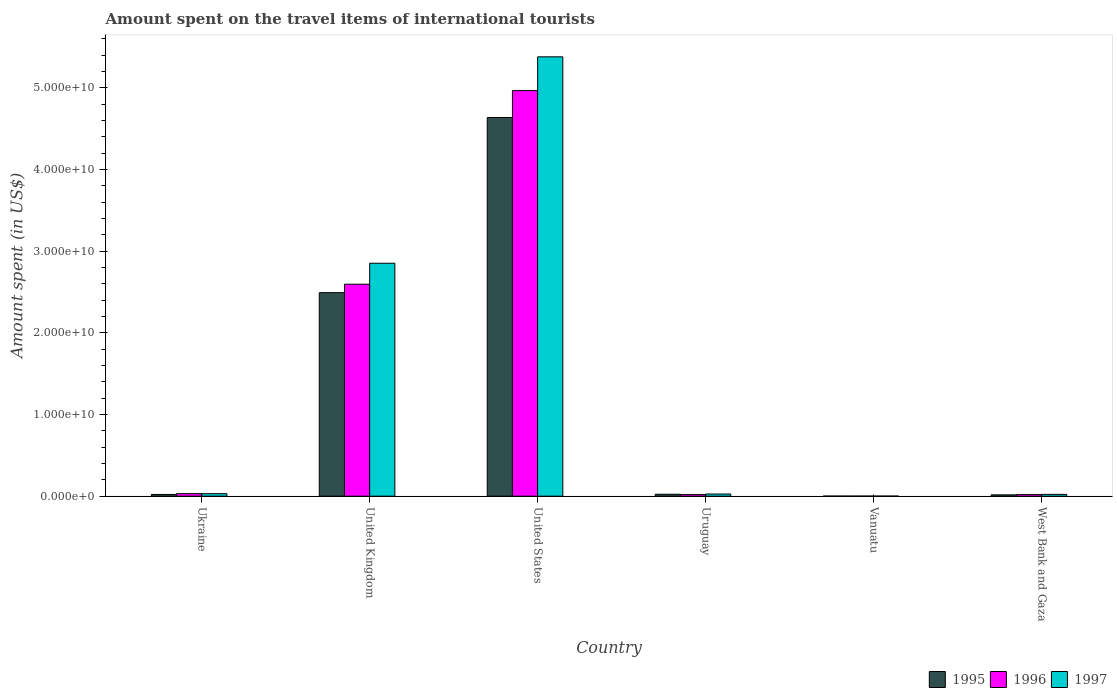How many different coloured bars are there?
Make the answer very short. 3. Are the number of bars per tick equal to the number of legend labels?
Give a very brief answer. Yes. Are the number of bars on each tick of the X-axis equal?
Give a very brief answer. Yes. How many bars are there on the 1st tick from the right?
Provide a succinct answer. 3. What is the label of the 1st group of bars from the left?
Make the answer very short. Ukraine. In how many cases, is the number of bars for a given country not equal to the number of legend labels?
Give a very brief answer. 0. What is the amount spent on the travel items of international tourists in 1995 in Vanuatu?
Give a very brief answer. 5.00e+06. Across all countries, what is the maximum amount spent on the travel items of international tourists in 1996?
Your response must be concise. 4.97e+1. In which country was the amount spent on the travel items of international tourists in 1995 maximum?
Provide a succinct answer. United States. In which country was the amount spent on the travel items of international tourists in 1996 minimum?
Ensure brevity in your answer.  Vanuatu. What is the total amount spent on the travel items of international tourists in 1997 in the graph?
Ensure brevity in your answer.  8.31e+1. What is the difference between the amount spent on the travel items of international tourists in 1996 in Ukraine and that in West Bank and Gaza?
Your answer should be compact. 1.17e+08. What is the difference between the amount spent on the travel items of international tourists in 1996 in West Bank and Gaza and the amount spent on the travel items of international tourists in 1995 in United Kingdom?
Keep it short and to the point. -2.47e+1. What is the average amount spent on the travel items of international tourists in 1996 per country?
Ensure brevity in your answer.  1.27e+1. What is the difference between the amount spent on the travel items of international tourists of/in 1995 and amount spent on the travel items of international tourists of/in 1997 in United States?
Your answer should be very brief. -7.43e+09. What is the ratio of the amount spent on the travel items of international tourists in 1996 in Ukraine to that in United States?
Make the answer very short. 0.01. Is the difference between the amount spent on the travel items of international tourists in 1995 in Uruguay and Vanuatu greater than the difference between the amount spent on the travel items of international tourists in 1997 in Uruguay and Vanuatu?
Offer a terse response. No. What is the difference between the highest and the second highest amount spent on the travel items of international tourists in 1995?
Offer a terse response. 4.61e+1. What is the difference between the highest and the lowest amount spent on the travel items of international tourists in 1997?
Offer a terse response. 5.38e+1. In how many countries, is the amount spent on the travel items of international tourists in 1996 greater than the average amount spent on the travel items of international tourists in 1996 taken over all countries?
Your answer should be very brief. 2. What does the 3rd bar from the left in Uruguay represents?
Your answer should be compact. 1997. What does the 3rd bar from the right in West Bank and Gaza represents?
Provide a succinct answer. 1995. How many countries are there in the graph?
Make the answer very short. 6. Are the values on the major ticks of Y-axis written in scientific E-notation?
Keep it short and to the point. Yes. Does the graph contain any zero values?
Give a very brief answer. No. Does the graph contain grids?
Give a very brief answer. No. How many legend labels are there?
Offer a very short reply. 3. What is the title of the graph?
Your response must be concise. Amount spent on the travel items of international tourists. What is the label or title of the X-axis?
Ensure brevity in your answer.  Country. What is the label or title of the Y-axis?
Your answer should be very brief. Amount spent (in US$). What is the Amount spent (in US$) in 1995 in Ukraine?
Your answer should be very brief. 2.10e+08. What is the Amount spent (in US$) in 1996 in Ukraine?
Provide a short and direct response. 3.08e+08. What is the Amount spent (in US$) in 1997 in Ukraine?
Offer a very short reply. 3.05e+08. What is the Amount spent (in US$) in 1995 in United Kingdom?
Your answer should be very brief. 2.49e+1. What is the Amount spent (in US$) of 1996 in United Kingdom?
Your answer should be compact. 2.60e+1. What is the Amount spent (in US$) in 1997 in United Kingdom?
Keep it short and to the point. 2.85e+1. What is the Amount spent (in US$) in 1995 in United States?
Offer a very short reply. 4.64e+1. What is the Amount spent (in US$) in 1996 in United States?
Offer a very short reply. 4.97e+1. What is the Amount spent (in US$) of 1997 in United States?
Offer a terse response. 5.38e+1. What is the Amount spent (in US$) in 1995 in Uruguay?
Give a very brief answer. 2.36e+08. What is the Amount spent (in US$) of 1996 in Uruguay?
Offer a very short reply. 1.92e+08. What is the Amount spent (in US$) of 1997 in Uruguay?
Your response must be concise. 2.64e+08. What is the Amount spent (in US$) in 1996 in Vanuatu?
Provide a succinct answer. 5.00e+06. What is the Amount spent (in US$) in 1995 in West Bank and Gaza?
Your answer should be very brief. 1.62e+08. What is the Amount spent (in US$) of 1996 in West Bank and Gaza?
Offer a terse response. 1.91e+08. What is the Amount spent (in US$) in 1997 in West Bank and Gaza?
Your response must be concise. 2.18e+08. Across all countries, what is the maximum Amount spent (in US$) of 1995?
Provide a succinct answer. 4.64e+1. Across all countries, what is the maximum Amount spent (in US$) of 1996?
Offer a terse response. 4.97e+1. Across all countries, what is the maximum Amount spent (in US$) of 1997?
Keep it short and to the point. 5.38e+1. Across all countries, what is the minimum Amount spent (in US$) of 1996?
Your answer should be compact. 5.00e+06. What is the total Amount spent (in US$) in 1995 in the graph?
Keep it short and to the point. 7.19e+1. What is the total Amount spent (in US$) of 1996 in the graph?
Provide a succinct answer. 7.63e+1. What is the total Amount spent (in US$) in 1997 in the graph?
Offer a terse response. 8.31e+1. What is the difference between the Amount spent (in US$) in 1995 in Ukraine and that in United Kingdom?
Your answer should be compact. -2.47e+1. What is the difference between the Amount spent (in US$) of 1996 in Ukraine and that in United Kingdom?
Your response must be concise. -2.57e+1. What is the difference between the Amount spent (in US$) in 1997 in Ukraine and that in United Kingdom?
Provide a short and direct response. -2.82e+1. What is the difference between the Amount spent (in US$) of 1995 in Ukraine and that in United States?
Make the answer very short. -4.62e+1. What is the difference between the Amount spent (in US$) in 1996 in Ukraine and that in United States?
Your answer should be compact. -4.94e+1. What is the difference between the Amount spent (in US$) of 1997 in Ukraine and that in United States?
Ensure brevity in your answer.  -5.35e+1. What is the difference between the Amount spent (in US$) of 1995 in Ukraine and that in Uruguay?
Make the answer very short. -2.60e+07. What is the difference between the Amount spent (in US$) in 1996 in Ukraine and that in Uruguay?
Make the answer very short. 1.16e+08. What is the difference between the Amount spent (in US$) of 1997 in Ukraine and that in Uruguay?
Your answer should be very brief. 4.10e+07. What is the difference between the Amount spent (in US$) in 1995 in Ukraine and that in Vanuatu?
Offer a very short reply. 2.05e+08. What is the difference between the Amount spent (in US$) of 1996 in Ukraine and that in Vanuatu?
Your answer should be very brief. 3.03e+08. What is the difference between the Amount spent (in US$) of 1997 in Ukraine and that in Vanuatu?
Make the answer very short. 3.00e+08. What is the difference between the Amount spent (in US$) of 1995 in Ukraine and that in West Bank and Gaza?
Offer a very short reply. 4.80e+07. What is the difference between the Amount spent (in US$) in 1996 in Ukraine and that in West Bank and Gaza?
Provide a short and direct response. 1.17e+08. What is the difference between the Amount spent (in US$) of 1997 in Ukraine and that in West Bank and Gaza?
Make the answer very short. 8.70e+07. What is the difference between the Amount spent (in US$) in 1995 in United Kingdom and that in United States?
Your answer should be very brief. -2.15e+1. What is the difference between the Amount spent (in US$) of 1996 in United Kingdom and that in United States?
Make the answer very short. -2.37e+1. What is the difference between the Amount spent (in US$) of 1997 in United Kingdom and that in United States?
Ensure brevity in your answer.  -2.53e+1. What is the difference between the Amount spent (in US$) of 1995 in United Kingdom and that in Uruguay?
Your response must be concise. 2.47e+1. What is the difference between the Amount spent (in US$) in 1996 in United Kingdom and that in Uruguay?
Make the answer very short. 2.58e+1. What is the difference between the Amount spent (in US$) in 1997 in United Kingdom and that in Uruguay?
Make the answer very short. 2.83e+1. What is the difference between the Amount spent (in US$) in 1995 in United Kingdom and that in Vanuatu?
Offer a terse response. 2.49e+1. What is the difference between the Amount spent (in US$) in 1996 in United Kingdom and that in Vanuatu?
Provide a short and direct response. 2.60e+1. What is the difference between the Amount spent (in US$) in 1997 in United Kingdom and that in Vanuatu?
Provide a succinct answer. 2.85e+1. What is the difference between the Amount spent (in US$) in 1995 in United Kingdom and that in West Bank and Gaza?
Give a very brief answer. 2.48e+1. What is the difference between the Amount spent (in US$) in 1996 in United Kingdom and that in West Bank and Gaza?
Provide a short and direct response. 2.58e+1. What is the difference between the Amount spent (in US$) of 1997 in United Kingdom and that in West Bank and Gaza?
Ensure brevity in your answer.  2.83e+1. What is the difference between the Amount spent (in US$) of 1995 in United States and that in Uruguay?
Provide a short and direct response. 4.61e+1. What is the difference between the Amount spent (in US$) of 1996 in United States and that in Uruguay?
Ensure brevity in your answer.  4.95e+1. What is the difference between the Amount spent (in US$) of 1997 in United States and that in Uruguay?
Give a very brief answer. 5.35e+1. What is the difference between the Amount spent (in US$) in 1995 in United States and that in Vanuatu?
Provide a succinct answer. 4.64e+1. What is the difference between the Amount spent (in US$) in 1996 in United States and that in Vanuatu?
Your answer should be compact. 4.97e+1. What is the difference between the Amount spent (in US$) of 1997 in United States and that in Vanuatu?
Offer a terse response. 5.38e+1. What is the difference between the Amount spent (in US$) of 1995 in United States and that in West Bank and Gaza?
Provide a succinct answer. 4.62e+1. What is the difference between the Amount spent (in US$) in 1996 in United States and that in West Bank and Gaza?
Offer a terse response. 4.95e+1. What is the difference between the Amount spent (in US$) in 1997 in United States and that in West Bank and Gaza?
Provide a succinct answer. 5.36e+1. What is the difference between the Amount spent (in US$) in 1995 in Uruguay and that in Vanuatu?
Your answer should be very brief. 2.31e+08. What is the difference between the Amount spent (in US$) of 1996 in Uruguay and that in Vanuatu?
Ensure brevity in your answer.  1.87e+08. What is the difference between the Amount spent (in US$) in 1997 in Uruguay and that in Vanuatu?
Your answer should be compact. 2.59e+08. What is the difference between the Amount spent (in US$) in 1995 in Uruguay and that in West Bank and Gaza?
Ensure brevity in your answer.  7.40e+07. What is the difference between the Amount spent (in US$) of 1996 in Uruguay and that in West Bank and Gaza?
Your answer should be very brief. 1.00e+06. What is the difference between the Amount spent (in US$) in 1997 in Uruguay and that in West Bank and Gaza?
Keep it short and to the point. 4.60e+07. What is the difference between the Amount spent (in US$) of 1995 in Vanuatu and that in West Bank and Gaza?
Your answer should be compact. -1.57e+08. What is the difference between the Amount spent (in US$) of 1996 in Vanuatu and that in West Bank and Gaza?
Make the answer very short. -1.86e+08. What is the difference between the Amount spent (in US$) in 1997 in Vanuatu and that in West Bank and Gaza?
Provide a short and direct response. -2.13e+08. What is the difference between the Amount spent (in US$) of 1995 in Ukraine and the Amount spent (in US$) of 1996 in United Kingdom?
Make the answer very short. -2.58e+1. What is the difference between the Amount spent (in US$) in 1995 in Ukraine and the Amount spent (in US$) in 1997 in United Kingdom?
Your answer should be very brief. -2.83e+1. What is the difference between the Amount spent (in US$) of 1996 in Ukraine and the Amount spent (in US$) of 1997 in United Kingdom?
Keep it short and to the point. -2.82e+1. What is the difference between the Amount spent (in US$) of 1995 in Ukraine and the Amount spent (in US$) of 1996 in United States?
Ensure brevity in your answer.  -4.95e+1. What is the difference between the Amount spent (in US$) of 1995 in Ukraine and the Amount spent (in US$) of 1997 in United States?
Keep it short and to the point. -5.36e+1. What is the difference between the Amount spent (in US$) of 1996 in Ukraine and the Amount spent (in US$) of 1997 in United States?
Make the answer very short. -5.35e+1. What is the difference between the Amount spent (in US$) of 1995 in Ukraine and the Amount spent (in US$) of 1996 in Uruguay?
Ensure brevity in your answer.  1.80e+07. What is the difference between the Amount spent (in US$) in 1995 in Ukraine and the Amount spent (in US$) in 1997 in Uruguay?
Offer a very short reply. -5.40e+07. What is the difference between the Amount spent (in US$) in 1996 in Ukraine and the Amount spent (in US$) in 1997 in Uruguay?
Make the answer very short. 4.40e+07. What is the difference between the Amount spent (in US$) in 1995 in Ukraine and the Amount spent (in US$) in 1996 in Vanuatu?
Provide a succinct answer. 2.05e+08. What is the difference between the Amount spent (in US$) in 1995 in Ukraine and the Amount spent (in US$) in 1997 in Vanuatu?
Provide a short and direct response. 2.05e+08. What is the difference between the Amount spent (in US$) of 1996 in Ukraine and the Amount spent (in US$) of 1997 in Vanuatu?
Offer a very short reply. 3.03e+08. What is the difference between the Amount spent (in US$) in 1995 in Ukraine and the Amount spent (in US$) in 1996 in West Bank and Gaza?
Your answer should be very brief. 1.90e+07. What is the difference between the Amount spent (in US$) in 1995 in Ukraine and the Amount spent (in US$) in 1997 in West Bank and Gaza?
Your response must be concise. -8.00e+06. What is the difference between the Amount spent (in US$) in 1996 in Ukraine and the Amount spent (in US$) in 1997 in West Bank and Gaza?
Your answer should be compact. 9.00e+07. What is the difference between the Amount spent (in US$) in 1995 in United Kingdom and the Amount spent (in US$) in 1996 in United States?
Your answer should be compact. -2.47e+1. What is the difference between the Amount spent (in US$) of 1995 in United Kingdom and the Amount spent (in US$) of 1997 in United States?
Offer a very short reply. -2.89e+1. What is the difference between the Amount spent (in US$) of 1996 in United Kingdom and the Amount spent (in US$) of 1997 in United States?
Offer a terse response. -2.78e+1. What is the difference between the Amount spent (in US$) in 1995 in United Kingdom and the Amount spent (in US$) in 1996 in Uruguay?
Provide a short and direct response. 2.47e+1. What is the difference between the Amount spent (in US$) of 1995 in United Kingdom and the Amount spent (in US$) of 1997 in Uruguay?
Provide a short and direct response. 2.47e+1. What is the difference between the Amount spent (in US$) of 1996 in United Kingdom and the Amount spent (in US$) of 1997 in Uruguay?
Your response must be concise. 2.57e+1. What is the difference between the Amount spent (in US$) of 1995 in United Kingdom and the Amount spent (in US$) of 1996 in Vanuatu?
Provide a succinct answer. 2.49e+1. What is the difference between the Amount spent (in US$) of 1995 in United Kingdom and the Amount spent (in US$) of 1997 in Vanuatu?
Ensure brevity in your answer.  2.49e+1. What is the difference between the Amount spent (in US$) of 1996 in United Kingdom and the Amount spent (in US$) of 1997 in Vanuatu?
Your answer should be compact. 2.60e+1. What is the difference between the Amount spent (in US$) of 1995 in United Kingdom and the Amount spent (in US$) of 1996 in West Bank and Gaza?
Give a very brief answer. 2.47e+1. What is the difference between the Amount spent (in US$) of 1995 in United Kingdom and the Amount spent (in US$) of 1997 in West Bank and Gaza?
Ensure brevity in your answer.  2.47e+1. What is the difference between the Amount spent (in US$) of 1996 in United Kingdom and the Amount spent (in US$) of 1997 in West Bank and Gaza?
Ensure brevity in your answer.  2.57e+1. What is the difference between the Amount spent (in US$) in 1995 in United States and the Amount spent (in US$) in 1996 in Uruguay?
Give a very brief answer. 4.62e+1. What is the difference between the Amount spent (in US$) of 1995 in United States and the Amount spent (in US$) of 1997 in Uruguay?
Provide a short and direct response. 4.61e+1. What is the difference between the Amount spent (in US$) in 1996 in United States and the Amount spent (in US$) in 1997 in Uruguay?
Provide a succinct answer. 4.94e+1. What is the difference between the Amount spent (in US$) of 1995 in United States and the Amount spent (in US$) of 1996 in Vanuatu?
Your answer should be compact. 4.64e+1. What is the difference between the Amount spent (in US$) in 1995 in United States and the Amount spent (in US$) in 1997 in Vanuatu?
Provide a short and direct response. 4.64e+1. What is the difference between the Amount spent (in US$) in 1996 in United States and the Amount spent (in US$) in 1997 in Vanuatu?
Your answer should be very brief. 4.97e+1. What is the difference between the Amount spent (in US$) in 1995 in United States and the Amount spent (in US$) in 1996 in West Bank and Gaza?
Your answer should be very brief. 4.62e+1. What is the difference between the Amount spent (in US$) of 1995 in United States and the Amount spent (in US$) of 1997 in West Bank and Gaza?
Ensure brevity in your answer.  4.62e+1. What is the difference between the Amount spent (in US$) of 1996 in United States and the Amount spent (in US$) of 1997 in West Bank and Gaza?
Keep it short and to the point. 4.95e+1. What is the difference between the Amount spent (in US$) in 1995 in Uruguay and the Amount spent (in US$) in 1996 in Vanuatu?
Provide a short and direct response. 2.31e+08. What is the difference between the Amount spent (in US$) of 1995 in Uruguay and the Amount spent (in US$) of 1997 in Vanuatu?
Your response must be concise. 2.31e+08. What is the difference between the Amount spent (in US$) of 1996 in Uruguay and the Amount spent (in US$) of 1997 in Vanuatu?
Make the answer very short. 1.87e+08. What is the difference between the Amount spent (in US$) of 1995 in Uruguay and the Amount spent (in US$) of 1996 in West Bank and Gaza?
Ensure brevity in your answer.  4.50e+07. What is the difference between the Amount spent (in US$) of 1995 in Uruguay and the Amount spent (in US$) of 1997 in West Bank and Gaza?
Your answer should be compact. 1.80e+07. What is the difference between the Amount spent (in US$) in 1996 in Uruguay and the Amount spent (in US$) in 1997 in West Bank and Gaza?
Offer a very short reply. -2.60e+07. What is the difference between the Amount spent (in US$) of 1995 in Vanuatu and the Amount spent (in US$) of 1996 in West Bank and Gaza?
Your response must be concise. -1.86e+08. What is the difference between the Amount spent (in US$) of 1995 in Vanuatu and the Amount spent (in US$) of 1997 in West Bank and Gaza?
Provide a succinct answer. -2.13e+08. What is the difference between the Amount spent (in US$) of 1996 in Vanuatu and the Amount spent (in US$) of 1997 in West Bank and Gaza?
Your answer should be very brief. -2.13e+08. What is the average Amount spent (in US$) of 1995 per country?
Keep it short and to the point. 1.20e+1. What is the average Amount spent (in US$) in 1996 per country?
Give a very brief answer. 1.27e+1. What is the average Amount spent (in US$) in 1997 per country?
Your response must be concise. 1.39e+1. What is the difference between the Amount spent (in US$) in 1995 and Amount spent (in US$) in 1996 in Ukraine?
Offer a terse response. -9.80e+07. What is the difference between the Amount spent (in US$) in 1995 and Amount spent (in US$) in 1997 in Ukraine?
Your answer should be compact. -9.50e+07. What is the difference between the Amount spent (in US$) of 1995 and Amount spent (in US$) of 1996 in United Kingdom?
Your response must be concise. -1.04e+09. What is the difference between the Amount spent (in US$) in 1995 and Amount spent (in US$) in 1997 in United Kingdom?
Your answer should be compact. -3.60e+09. What is the difference between the Amount spent (in US$) of 1996 and Amount spent (in US$) of 1997 in United Kingdom?
Give a very brief answer. -2.57e+09. What is the difference between the Amount spent (in US$) of 1995 and Amount spent (in US$) of 1996 in United States?
Your response must be concise. -3.29e+09. What is the difference between the Amount spent (in US$) of 1995 and Amount spent (in US$) of 1997 in United States?
Keep it short and to the point. -7.43e+09. What is the difference between the Amount spent (in US$) in 1996 and Amount spent (in US$) in 1997 in United States?
Give a very brief answer. -4.14e+09. What is the difference between the Amount spent (in US$) in 1995 and Amount spent (in US$) in 1996 in Uruguay?
Your answer should be very brief. 4.40e+07. What is the difference between the Amount spent (in US$) of 1995 and Amount spent (in US$) of 1997 in Uruguay?
Ensure brevity in your answer.  -2.80e+07. What is the difference between the Amount spent (in US$) in 1996 and Amount spent (in US$) in 1997 in Uruguay?
Your answer should be very brief. -7.20e+07. What is the difference between the Amount spent (in US$) of 1995 and Amount spent (in US$) of 1996 in Vanuatu?
Your answer should be compact. 0. What is the difference between the Amount spent (in US$) in 1996 and Amount spent (in US$) in 1997 in Vanuatu?
Keep it short and to the point. 0. What is the difference between the Amount spent (in US$) of 1995 and Amount spent (in US$) of 1996 in West Bank and Gaza?
Provide a succinct answer. -2.90e+07. What is the difference between the Amount spent (in US$) of 1995 and Amount spent (in US$) of 1997 in West Bank and Gaza?
Provide a succinct answer. -5.60e+07. What is the difference between the Amount spent (in US$) in 1996 and Amount spent (in US$) in 1997 in West Bank and Gaza?
Keep it short and to the point. -2.70e+07. What is the ratio of the Amount spent (in US$) of 1995 in Ukraine to that in United Kingdom?
Give a very brief answer. 0.01. What is the ratio of the Amount spent (in US$) of 1996 in Ukraine to that in United Kingdom?
Your response must be concise. 0.01. What is the ratio of the Amount spent (in US$) in 1997 in Ukraine to that in United Kingdom?
Your answer should be very brief. 0.01. What is the ratio of the Amount spent (in US$) of 1995 in Ukraine to that in United States?
Keep it short and to the point. 0. What is the ratio of the Amount spent (in US$) of 1996 in Ukraine to that in United States?
Your response must be concise. 0.01. What is the ratio of the Amount spent (in US$) of 1997 in Ukraine to that in United States?
Give a very brief answer. 0.01. What is the ratio of the Amount spent (in US$) in 1995 in Ukraine to that in Uruguay?
Your answer should be very brief. 0.89. What is the ratio of the Amount spent (in US$) in 1996 in Ukraine to that in Uruguay?
Your answer should be compact. 1.6. What is the ratio of the Amount spent (in US$) in 1997 in Ukraine to that in Uruguay?
Your answer should be very brief. 1.16. What is the ratio of the Amount spent (in US$) of 1995 in Ukraine to that in Vanuatu?
Keep it short and to the point. 42. What is the ratio of the Amount spent (in US$) of 1996 in Ukraine to that in Vanuatu?
Provide a succinct answer. 61.6. What is the ratio of the Amount spent (in US$) in 1997 in Ukraine to that in Vanuatu?
Offer a terse response. 61. What is the ratio of the Amount spent (in US$) of 1995 in Ukraine to that in West Bank and Gaza?
Offer a terse response. 1.3. What is the ratio of the Amount spent (in US$) of 1996 in Ukraine to that in West Bank and Gaza?
Offer a very short reply. 1.61. What is the ratio of the Amount spent (in US$) of 1997 in Ukraine to that in West Bank and Gaza?
Offer a terse response. 1.4. What is the ratio of the Amount spent (in US$) of 1995 in United Kingdom to that in United States?
Offer a very short reply. 0.54. What is the ratio of the Amount spent (in US$) of 1996 in United Kingdom to that in United States?
Provide a short and direct response. 0.52. What is the ratio of the Amount spent (in US$) in 1997 in United Kingdom to that in United States?
Provide a succinct answer. 0.53. What is the ratio of the Amount spent (in US$) of 1995 in United Kingdom to that in Uruguay?
Give a very brief answer. 105.62. What is the ratio of the Amount spent (in US$) of 1996 in United Kingdom to that in Uruguay?
Make the answer very short. 135.22. What is the ratio of the Amount spent (in US$) of 1997 in United Kingdom to that in Uruguay?
Offer a terse response. 108.06. What is the ratio of the Amount spent (in US$) in 1995 in United Kingdom to that in Vanuatu?
Give a very brief answer. 4985.2. What is the ratio of the Amount spent (in US$) in 1996 in United Kingdom to that in Vanuatu?
Provide a short and direct response. 5192.4. What is the ratio of the Amount spent (in US$) of 1997 in United Kingdom to that in Vanuatu?
Your response must be concise. 5705.8. What is the ratio of the Amount spent (in US$) in 1995 in United Kingdom to that in West Bank and Gaza?
Offer a terse response. 153.86. What is the ratio of the Amount spent (in US$) of 1996 in United Kingdom to that in West Bank and Gaza?
Keep it short and to the point. 135.93. What is the ratio of the Amount spent (in US$) of 1997 in United Kingdom to that in West Bank and Gaza?
Offer a terse response. 130.87. What is the ratio of the Amount spent (in US$) of 1995 in United States to that in Uruguay?
Your response must be concise. 196.52. What is the ratio of the Amount spent (in US$) of 1996 in United States to that in Uruguay?
Offer a terse response. 258.71. What is the ratio of the Amount spent (in US$) of 1997 in United States to that in Uruguay?
Your answer should be compact. 203.82. What is the ratio of the Amount spent (in US$) of 1995 in United States to that in Vanuatu?
Your response must be concise. 9275.8. What is the ratio of the Amount spent (in US$) in 1996 in United States to that in Vanuatu?
Your answer should be very brief. 9934.4. What is the ratio of the Amount spent (in US$) in 1997 in United States to that in Vanuatu?
Ensure brevity in your answer.  1.08e+04. What is the ratio of the Amount spent (in US$) in 1995 in United States to that in West Bank and Gaza?
Your answer should be compact. 286.29. What is the ratio of the Amount spent (in US$) of 1996 in United States to that in West Bank and Gaza?
Provide a succinct answer. 260.06. What is the ratio of the Amount spent (in US$) of 1997 in United States to that in West Bank and Gaza?
Give a very brief answer. 246.83. What is the ratio of the Amount spent (in US$) of 1995 in Uruguay to that in Vanuatu?
Give a very brief answer. 47.2. What is the ratio of the Amount spent (in US$) in 1996 in Uruguay to that in Vanuatu?
Offer a very short reply. 38.4. What is the ratio of the Amount spent (in US$) in 1997 in Uruguay to that in Vanuatu?
Provide a short and direct response. 52.8. What is the ratio of the Amount spent (in US$) in 1995 in Uruguay to that in West Bank and Gaza?
Provide a short and direct response. 1.46. What is the ratio of the Amount spent (in US$) in 1997 in Uruguay to that in West Bank and Gaza?
Provide a short and direct response. 1.21. What is the ratio of the Amount spent (in US$) of 1995 in Vanuatu to that in West Bank and Gaza?
Ensure brevity in your answer.  0.03. What is the ratio of the Amount spent (in US$) of 1996 in Vanuatu to that in West Bank and Gaza?
Offer a terse response. 0.03. What is the ratio of the Amount spent (in US$) in 1997 in Vanuatu to that in West Bank and Gaza?
Your answer should be compact. 0.02. What is the difference between the highest and the second highest Amount spent (in US$) of 1995?
Your answer should be compact. 2.15e+1. What is the difference between the highest and the second highest Amount spent (in US$) of 1996?
Make the answer very short. 2.37e+1. What is the difference between the highest and the second highest Amount spent (in US$) of 1997?
Make the answer very short. 2.53e+1. What is the difference between the highest and the lowest Amount spent (in US$) of 1995?
Make the answer very short. 4.64e+1. What is the difference between the highest and the lowest Amount spent (in US$) of 1996?
Provide a succinct answer. 4.97e+1. What is the difference between the highest and the lowest Amount spent (in US$) in 1997?
Keep it short and to the point. 5.38e+1. 